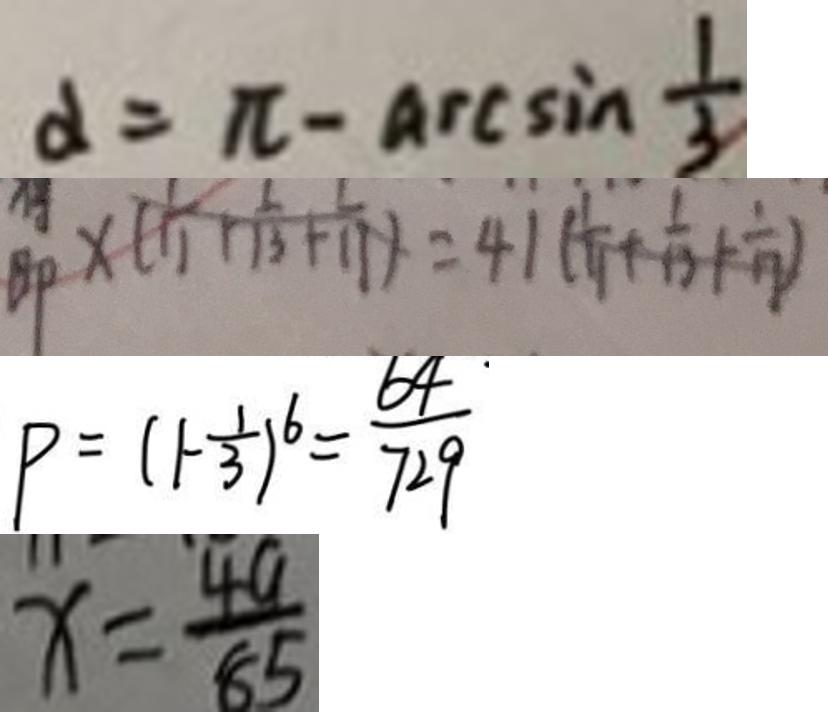<formula> <loc_0><loc_0><loc_500><loc_500>\alpha = \pi - \arcsin \frac { 1 } { 3 } 
 B P \times ( \frac { 1 } { 1 1 } + \frac { 1 } { 1 3 } + \frac { 1 } { 1 1 } ) = 4 1 ( \frac { 1 } { 1 1 } + \frac { 1 } { 1 3 } + \frac { 1 } { 1 7 } ) 
 P = ( 1 - \frac { 1 } { 3 } ) ^ { 6 } = \frac { 6 4 \cdot } { 7 2 9 } 
 x = \frac { 4 a } { 8 5 }</formula> 